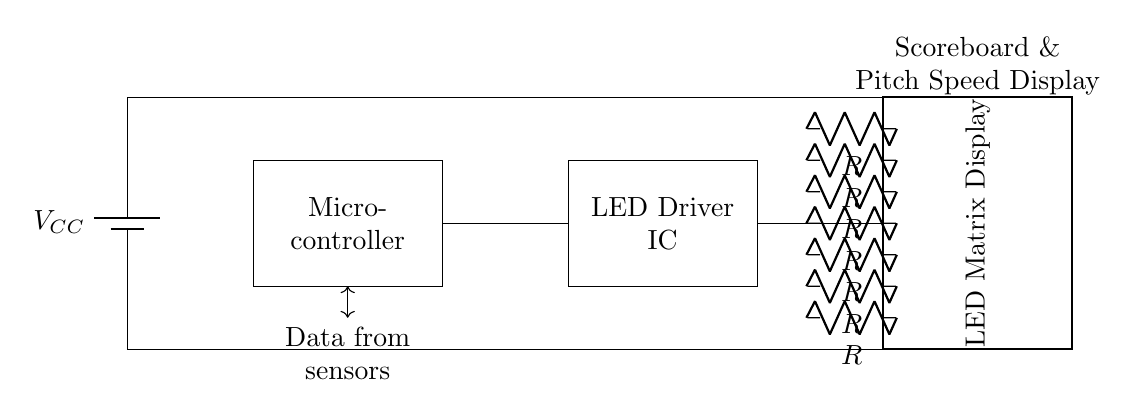What is the function of the microcontroller in this circuit? The microcontroller controls the operation of the circuit by processing data from sensors and sending commands to the LED Driver IC.
Answer: Control What does the LED Driver IC do? The LED Driver IC is responsible for providing the necessary current and voltage to operate the LED matrix display properly.
Answer: Drive LEDs What type of display is used in this circuit? The circuit employs an LED matrix display to show scores and pitch speed indicators.
Answer: LED matrix How many resistors are present in the circuit? There are seven resistors in the resistor network connected to the LED matrix display.
Answer: Seven What is the power source voltage labeled as in this diagram? The power source voltage is labeled as V_CC in the circuit diagram.
Answer: V_CC What is the purpose of the connections between the microcontroller and the LED Driver IC? The connections facilitate data transfer from the microcontroller to the LED Driver IC for controlling the LED display.
Answer: Data transfer 